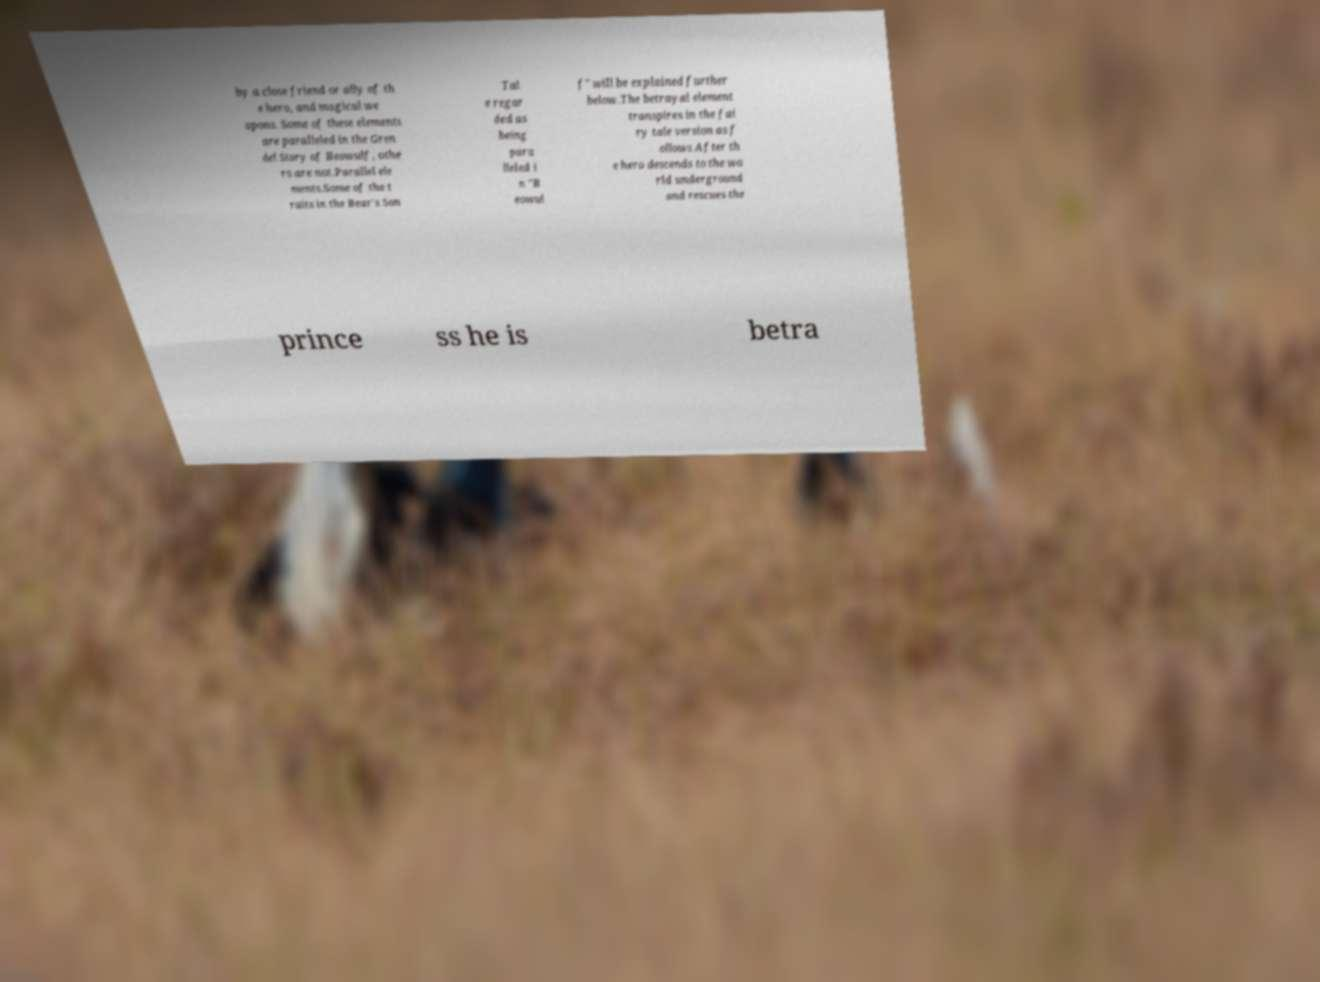Can you accurately transcribe the text from the provided image for me? by a close friend or ally of th e hero, and magical we apons. Some of these elements are paralleled in the Gren del Story of Beowulf, othe rs are not.Parallel ele ments.Some of the t raits in the Bear's Son Tal e regar ded as being para lleled i n "B eowul f" will be explained further below.The betrayal element transpires in the fai ry tale version as f ollows After th e hero descends to the wo rld underground and rescues the prince ss he is betra 